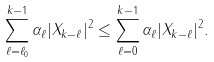<formula> <loc_0><loc_0><loc_500><loc_500>\sum _ { \ell = \ell _ { 0 } } ^ { k - 1 } \alpha _ { \ell } | X _ { k - \ell } | ^ { 2 } \leq \sum _ { \ell = 0 } ^ { k - 1 } \alpha _ { \ell } | X _ { k - \ell } | ^ { 2 } .</formula> 